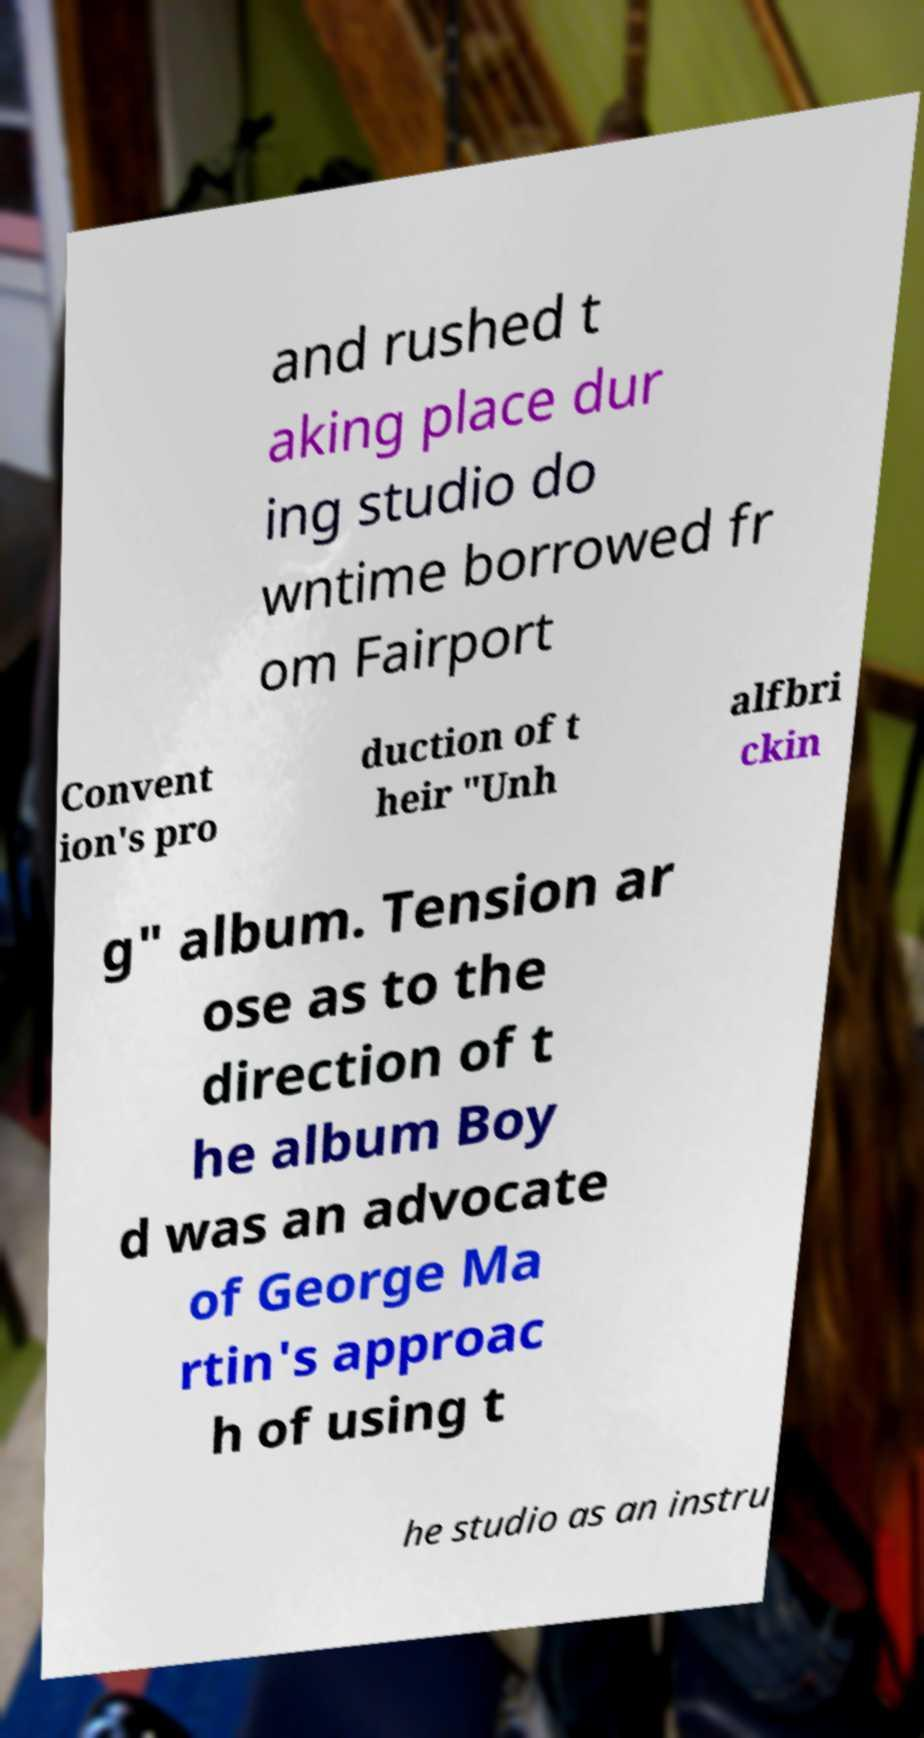Can you read and provide the text displayed in the image?This photo seems to have some interesting text. Can you extract and type it out for me? and rushed t aking place dur ing studio do wntime borrowed fr om Fairport Convent ion's pro duction of t heir "Unh alfbri ckin g" album. Tension ar ose as to the direction of t he album Boy d was an advocate of George Ma rtin's approac h of using t he studio as an instru 